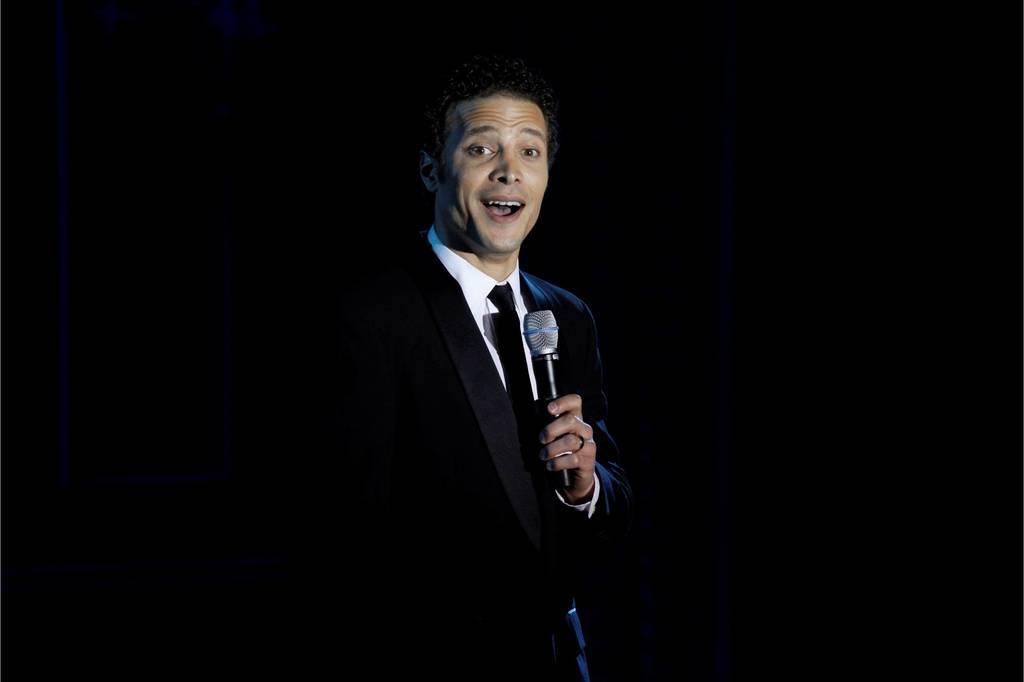Describe this image in one or two sentences. This is a picture of a man in black blazer holding a microphone and talking. Background of this man is in black color. 